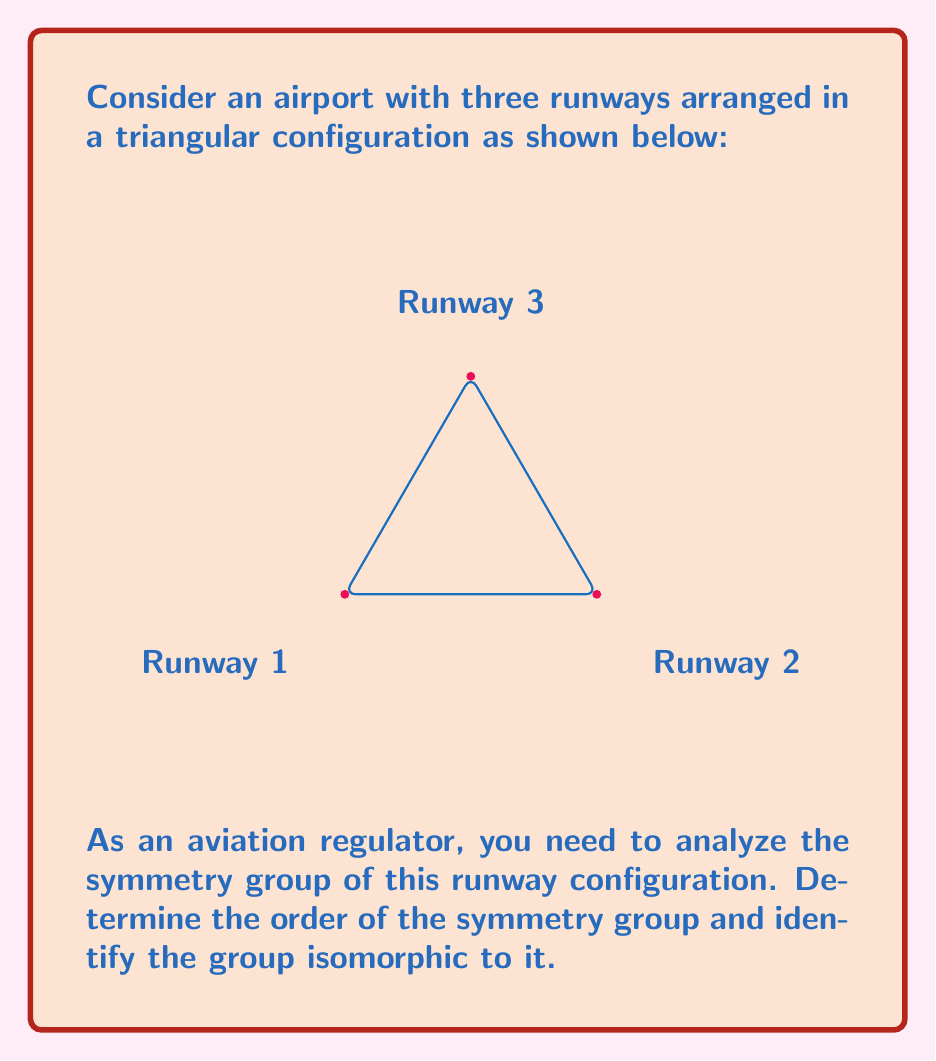Could you help me with this problem? Let's approach this step-by-step:

1) First, we need to identify all the symmetries of this triangular runway configuration:
   - Identity (do nothing)
   - 120° clockwise rotation
   - 240° clockwise rotation (or 120° counterclockwise)
   - Reflection across the altitude from Runway 1
   - Reflection across the altitude from Runway 2
   - Reflection across the altitude from Runway 3

2) We can see that there are 6 symmetries in total. This means the order of the symmetry group is 6.

3) Now, we need to identify which group of order 6 this symmetry group is isomorphic to. The two possibilities are:
   - Cyclic group $C_6$
   - Dihedral group $D_3$

4) To determine which one it is, we need to consider the structure of the symmetries:
   - We have rotations of order 3 (120°, 240°)
   - We have reflections of order 2

5) This structure matches the dihedral group $D_3$, which is defined as the symmetry group of a regular triangle.

6) The group operation table of $D_3$ would match the composition of these symmetries.

Therefore, the symmetry group of this runway configuration is isomorphic to $D_3$.
Answer: $D_3$, order 6 